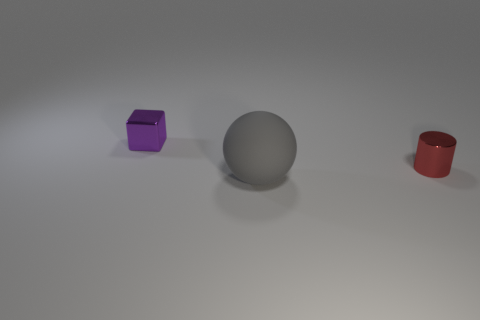Add 2 large gray rubber things. How many objects exist? 5 Subtract all cylinders. How many objects are left? 2 Add 2 tiny blocks. How many tiny blocks exist? 3 Subtract 0 purple cylinders. How many objects are left? 3 Subtract all big purple rubber spheres. Subtract all small purple cubes. How many objects are left? 2 Add 1 purple metallic objects. How many purple metallic objects are left? 2 